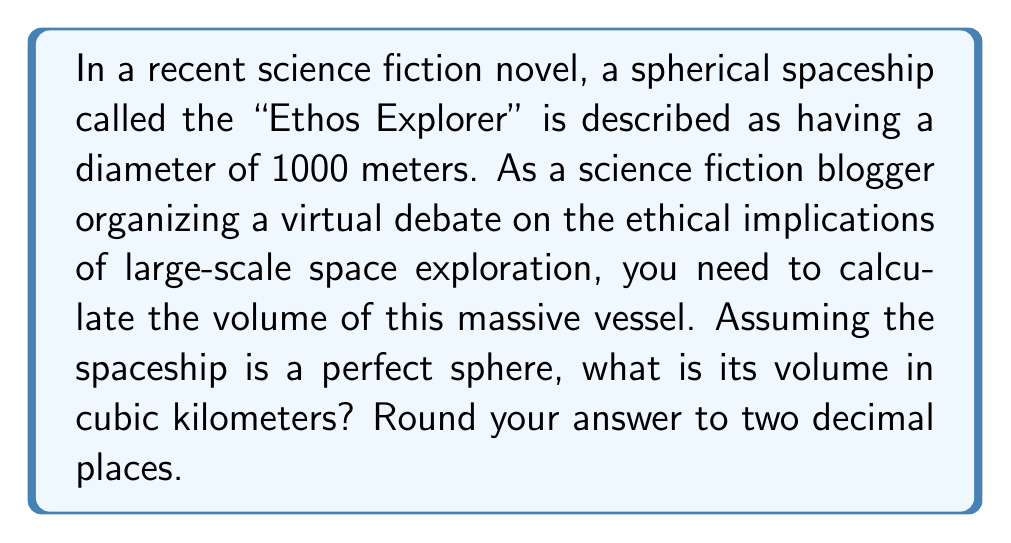Can you solve this math problem? To solve this problem, we'll use the formula for the volume of a sphere and follow these steps:

1. Recall the formula for the volume of a sphere:
   $$V = \frac{4}{3}\pi r^3$$
   where $V$ is the volume and $r$ is the radius.

2. We're given the diameter, so we need to calculate the radius:
   $$r = \frac{\text{diameter}}{2} = \frac{1000 \text{ m}}{2} = 500 \text{ m}$$

3. Now, let's substitute this into our volume formula:
   $$V = \frac{4}{3}\pi (500 \text{ m})^3$$

4. Simplify:
   $$V = \frac{4}{3}\pi \cdot 125,000,000 \text{ m}^3$$

5. Calculate (using $\pi \approx 3.14159$):
   $$V \approx 523,598,333.33 \text{ m}^3$$

6. Convert to cubic kilometers:
   $$V \approx 523,598,333.33 \text{ m}^3 \cdot \frac{1 \text{ km}^3}{1,000,000,000 \text{ m}^3} \approx 0.52359833333 \text{ km}^3$$

7. Round to two decimal places:
   $$V \approx 0.52 \text{ km}^3$$

[asy]
import geometry;

size(200);
draw(circle((0,0),1), blue);
draw((-1,0)--(1,0),dashed);
label("1000 m", (0,-1.2), S);
label("500 m", (0.5,0), SE);
dot((0,0));
[/asy]
Answer: The volume of the "Ethos Explorer" spherical spaceship is approximately $0.52 \text{ km}^3$. 